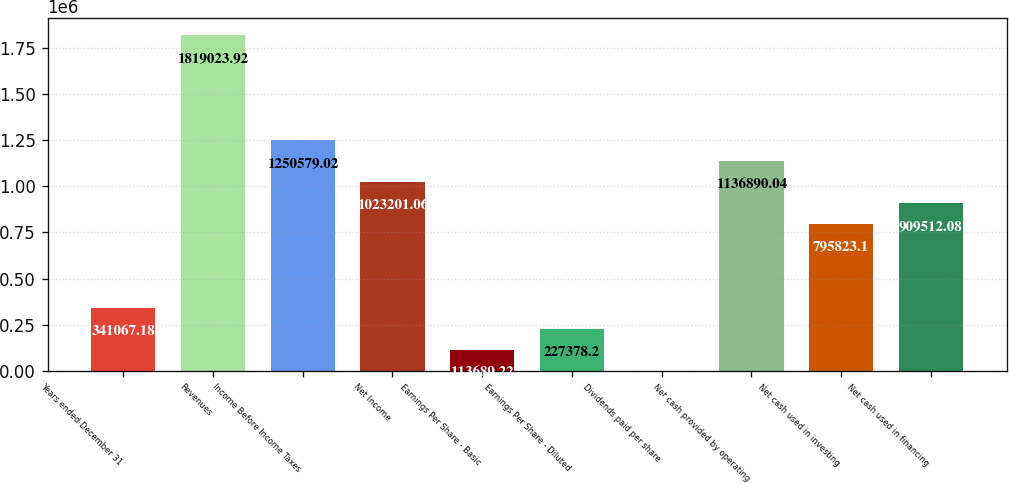Convert chart to OTSL. <chart><loc_0><loc_0><loc_500><loc_500><bar_chart><fcel>Years ended December 31<fcel>Revenues<fcel>Income Before Income Taxes<fcel>Net Income<fcel>Earnings Per Share - Basic<fcel>Earnings Per Share - Diluted<fcel>Dividends paid per share<fcel>Net cash provided by operating<fcel>Net cash used in investing<fcel>Net cash used in financing<nl><fcel>341067<fcel>1.81902e+06<fcel>1.25058e+06<fcel>1.0232e+06<fcel>113689<fcel>227378<fcel>0.24<fcel>1.13689e+06<fcel>795823<fcel>909512<nl></chart> 